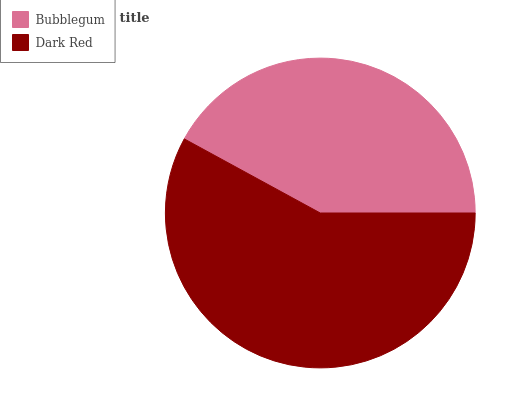Is Bubblegum the minimum?
Answer yes or no. Yes. Is Dark Red the maximum?
Answer yes or no. Yes. Is Dark Red the minimum?
Answer yes or no. No. Is Dark Red greater than Bubblegum?
Answer yes or no. Yes. Is Bubblegum less than Dark Red?
Answer yes or no. Yes. Is Bubblegum greater than Dark Red?
Answer yes or no. No. Is Dark Red less than Bubblegum?
Answer yes or no. No. Is Dark Red the high median?
Answer yes or no. Yes. Is Bubblegum the low median?
Answer yes or no. Yes. Is Bubblegum the high median?
Answer yes or no. No. Is Dark Red the low median?
Answer yes or no. No. 